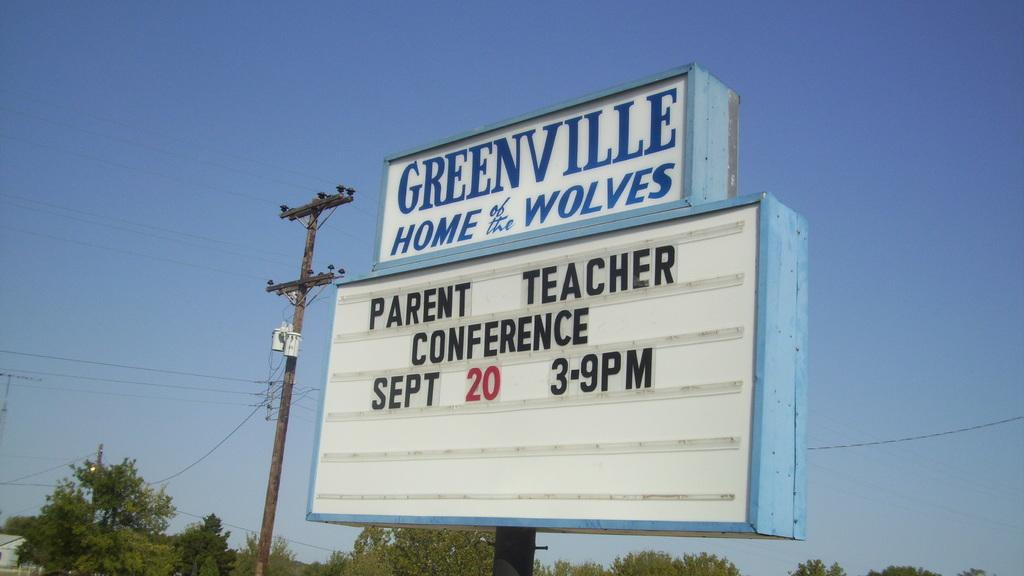<image>
Present a compact description of the photo's key features. a Greenville Home and Wolves parent teacher conference 